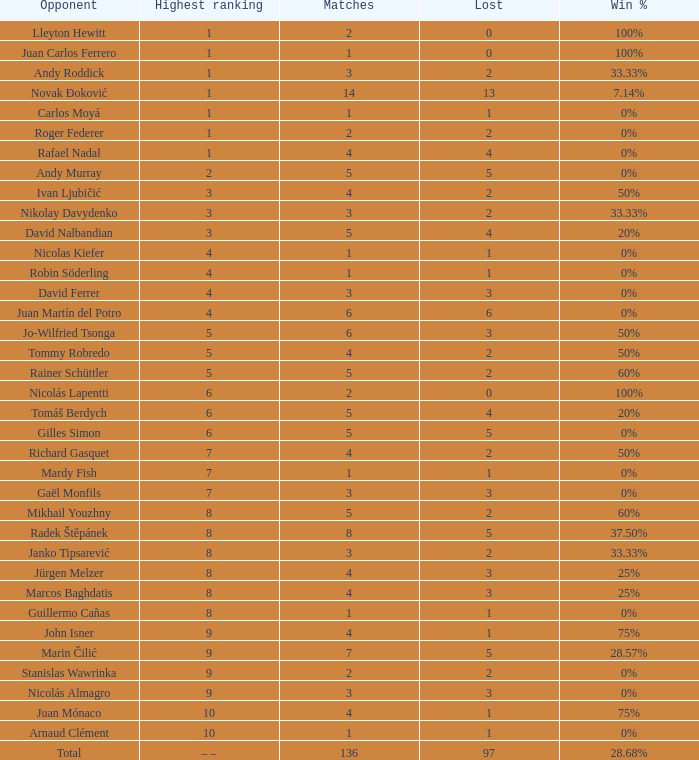What is the least amount of matches with under 97 losses and a win ratio of 2 None. 